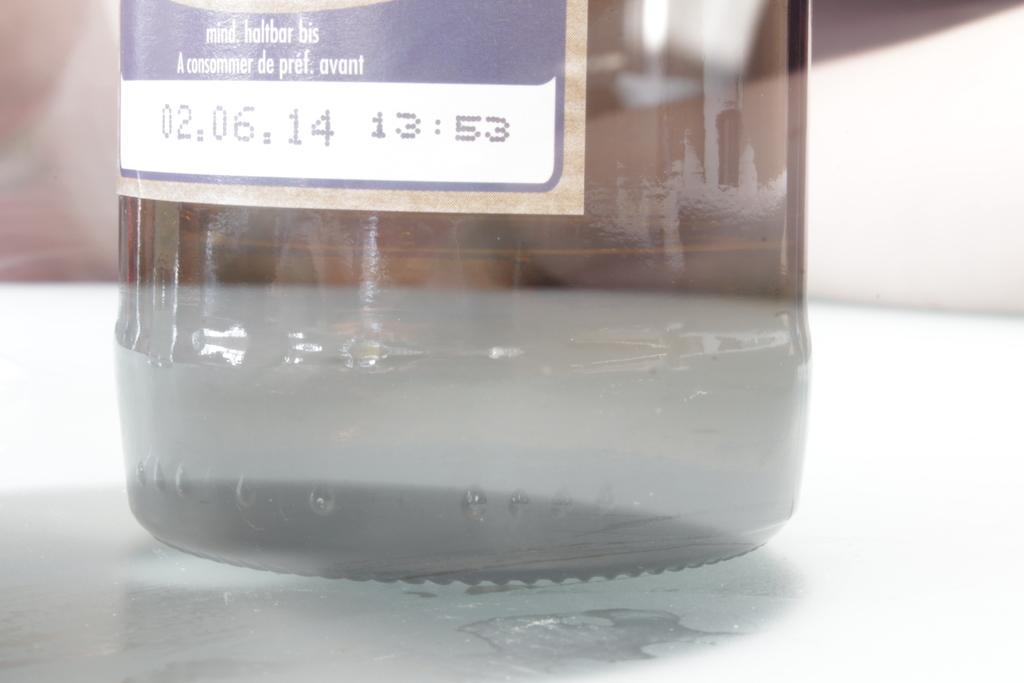What type of container is visible in the image? There is a glass bottle in the image. What type of stew is being cooked in the glass bottle in the image? There is no stew or cooking activity present in the image; it only features a glass bottle. 